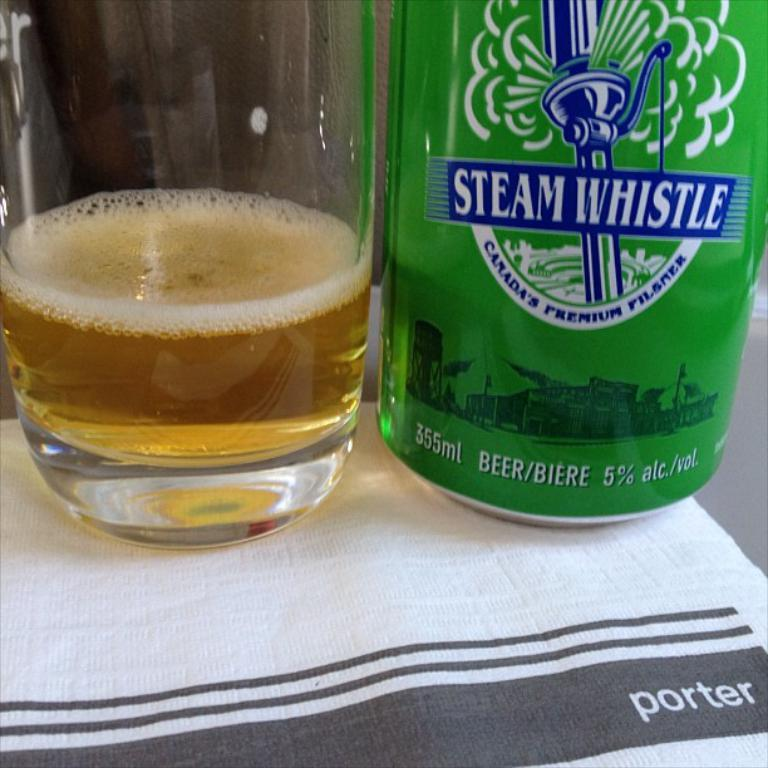<image>
Present a compact description of the photo's key features. A green bottle of Steam Whistle has a volume of 355 mL. 